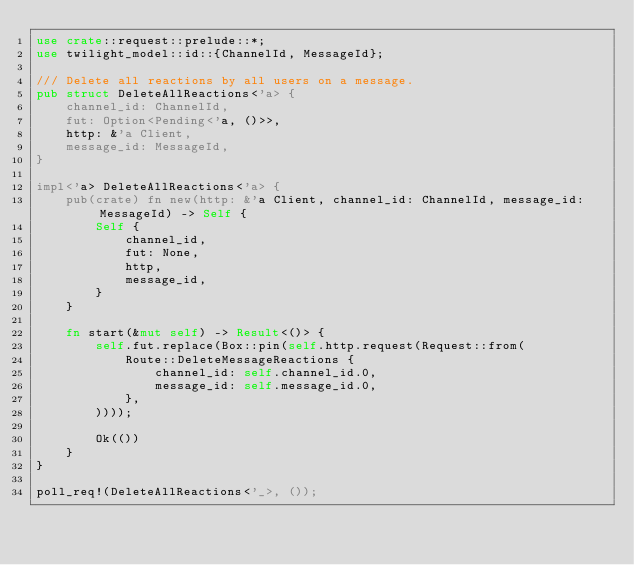Convert code to text. <code><loc_0><loc_0><loc_500><loc_500><_Rust_>use crate::request::prelude::*;
use twilight_model::id::{ChannelId, MessageId};

/// Delete all reactions by all users on a message.
pub struct DeleteAllReactions<'a> {
    channel_id: ChannelId,
    fut: Option<Pending<'a, ()>>,
    http: &'a Client,
    message_id: MessageId,
}

impl<'a> DeleteAllReactions<'a> {
    pub(crate) fn new(http: &'a Client, channel_id: ChannelId, message_id: MessageId) -> Self {
        Self {
            channel_id,
            fut: None,
            http,
            message_id,
        }
    }

    fn start(&mut self) -> Result<()> {
        self.fut.replace(Box::pin(self.http.request(Request::from(
            Route::DeleteMessageReactions {
                channel_id: self.channel_id.0,
                message_id: self.message_id.0,
            },
        ))));

        Ok(())
    }
}

poll_req!(DeleteAllReactions<'_>, ());
</code> 